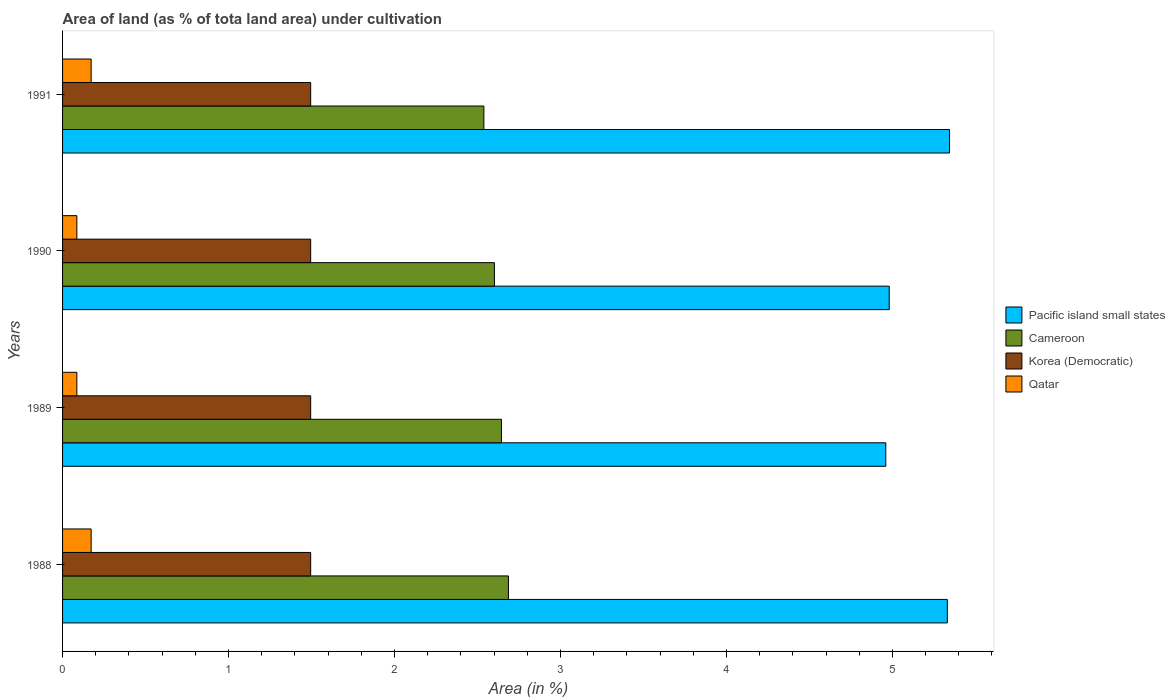How many different coloured bars are there?
Give a very brief answer. 4. Are the number of bars on each tick of the Y-axis equal?
Provide a succinct answer. Yes. How many bars are there on the 2nd tick from the bottom?
Your response must be concise. 4. What is the percentage of land under cultivation in Korea (Democratic) in 1991?
Offer a terse response. 1.49. Across all years, what is the maximum percentage of land under cultivation in Pacific island small states?
Your answer should be compact. 5.34. Across all years, what is the minimum percentage of land under cultivation in Cameroon?
Offer a very short reply. 2.54. In which year was the percentage of land under cultivation in Cameroon minimum?
Ensure brevity in your answer.  1991. What is the total percentage of land under cultivation in Pacific island small states in the graph?
Provide a short and direct response. 20.62. What is the difference between the percentage of land under cultivation in Korea (Democratic) in 1989 and that in 1991?
Offer a terse response. 0. What is the difference between the percentage of land under cultivation in Pacific island small states in 1988 and the percentage of land under cultivation in Cameroon in 1989?
Your answer should be very brief. 2.69. What is the average percentage of land under cultivation in Cameroon per year?
Your answer should be very brief. 2.62. In the year 1991, what is the difference between the percentage of land under cultivation in Korea (Democratic) and percentage of land under cultivation in Qatar?
Provide a succinct answer. 1.32. In how many years, is the percentage of land under cultivation in Qatar greater than 4.4 %?
Give a very brief answer. 0. What is the ratio of the percentage of land under cultivation in Cameroon in 1989 to that in 1991?
Your answer should be very brief. 1.04. Is the percentage of land under cultivation in Korea (Democratic) in 1988 less than that in 1989?
Keep it short and to the point. No. What is the difference between the highest and the second highest percentage of land under cultivation in Korea (Democratic)?
Your response must be concise. 0. What is the difference between the highest and the lowest percentage of land under cultivation in Pacific island small states?
Provide a short and direct response. 0.38. In how many years, is the percentage of land under cultivation in Pacific island small states greater than the average percentage of land under cultivation in Pacific island small states taken over all years?
Your answer should be very brief. 2. Is it the case that in every year, the sum of the percentage of land under cultivation in Pacific island small states and percentage of land under cultivation in Korea (Democratic) is greater than the sum of percentage of land under cultivation in Qatar and percentage of land under cultivation in Cameroon?
Provide a short and direct response. Yes. What does the 1st bar from the top in 1989 represents?
Your response must be concise. Qatar. What does the 1st bar from the bottom in 1990 represents?
Keep it short and to the point. Pacific island small states. Is it the case that in every year, the sum of the percentage of land under cultivation in Cameroon and percentage of land under cultivation in Qatar is greater than the percentage of land under cultivation in Korea (Democratic)?
Keep it short and to the point. Yes. How many bars are there?
Make the answer very short. 16. Are all the bars in the graph horizontal?
Offer a very short reply. Yes. Are the values on the major ticks of X-axis written in scientific E-notation?
Provide a succinct answer. No. Does the graph contain any zero values?
Offer a terse response. No. How are the legend labels stacked?
Keep it short and to the point. Vertical. What is the title of the graph?
Offer a terse response. Area of land (as % of tota land area) under cultivation. What is the label or title of the X-axis?
Keep it short and to the point. Area (in %). What is the Area (in %) of Pacific island small states in 1988?
Keep it short and to the point. 5.33. What is the Area (in %) of Cameroon in 1988?
Your answer should be compact. 2.69. What is the Area (in %) in Korea (Democratic) in 1988?
Offer a very short reply. 1.49. What is the Area (in %) in Qatar in 1988?
Offer a very short reply. 0.17. What is the Area (in %) in Pacific island small states in 1989?
Make the answer very short. 4.96. What is the Area (in %) of Cameroon in 1989?
Keep it short and to the point. 2.64. What is the Area (in %) of Korea (Democratic) in 1989?
Provide a succinct answer. 1.49. What is the Area (in %) of Qatar in 1989?
Provide a succinct answer. 0.09. What is the Area (in %) in Pacific island small states in 1990?
Provide a succinct answer. 4.98. What is the Area (in %) in Cameroon in 1990?
Your answer should be very brief. 2.6. What is the Area (in %) in Korea (Democratic) in 1990?
Your response must be concise. 1.49. What is the Area (in %) of Qatar in 1990?
Keep it short and to the point. 0.09. What is the Area (in %) in Pacific island small states in 1991?
Your response must be concise. 5.34. What is the Area (in %) of Cameroon in 1991?
Give a very brief answer. 2.54. What is the Area (in %) in Korea (Democratic) in 1991?
Give a very brief answer. 1.49. What is the Area (in %) of Qatar in 1991?
Your response must be concise. 0.17. Across all years, what is the maximum Area (in %) of Pacific island small states?
Your answer should be compact. 5.34. Across all years, what is the maximum Area (in %) in Cameroon?
Keep it short and to the point. 2.69. Across all years, what is the maximum Area (in %) of Korea (Democratic)?
Ensure brevity in your answer.  1.49. Across all years, what is the maximum Area (in %) of Qatar?
Your answer should be compact. 0.17. Across all years, what is the minimum Area (in %) in Pacific island small states?
Offer a very short reply. 4.96. Across all years, what is the minimum Area (in %) of Cameroon?
Make the answer very short. 2.54. Across all years, what is the minimum Area (in %) of Korea (Democratic)?
Provide a succinct answer. 1.49. Across all years, what is the minimum Area (in %) in Qatar?
Offer a terse response. 0.09. What is the total Area (in %) of Pacific island small states in the graph?
Offer a terse response. 20.62. What is the total Area (in %) in Cameroon in the graph?
Your answer should be compact. 10.47. What is the total Area (in %) in Korea (Democratic) in the graph?
Give a very brief answer. 5.98. What is the total Area (in %) in Qatar in the graph?
Your answer should be very brief. 0.52. What is the difference between the Area (in %) in Pacific island small states in 1988 and that in 1989?
Keep it short and to the point. 0.37. What is the difference between the Area (in %) in Cameroon in 1988 and that in 1989?
Ensure brevity in your answer.  0.04. What is the difference between the Area (in %) of Qatar in 1988 and that in 1989?
Provide a short and direct response. 0.09. What is the difference between the Area (in %) in Pacific island small states in 1988 and that in 1990?
Provide a succinct answer. 0.35. What is the difference between the Area (in %) of Cameroon in 1988 and that in 1990?
Provide a succinct answer. 0.08. What is the difference between the Area (in %) of Korea (Democratic) in 1988 and that in 1990?
Provide a succinct answer. 0. What is the difference between the Area (in %) of Qatar in 1988 and that in 1990?
Give a very brief answer. 0.09. What is the difference between the Area (in %) in Pacific island small states in 1988 and that in 1991?
Offer a terse response. -0.01. What is the difference between the Area (in %) of Cameroon in 1988 and that in 1991?
Provide a short and direct response. 0.15. What is the difference between the Area (in %) of Korea (Democratic) in 1988 and that in 1991?
Your answer should be very brief. 0. What is the difference between the Area (in %) of Qatar in 1988 and that in 1991?
Make the answer very short. 0. What is the difference between the Area (in %) of Pacific island small states in 1989 and that in 1990?
Provide a succinct answer. -0.02. What is the difference between the Area (in %) in Cameroon in 1989 and that in 1990?
Provide a succinct answer. 0.04. What is the difference between the Area (in %) in Pacific island small states in 1989 and that in 1991?
Keep it short and to the point. -0.38. What is the difference between the Area (in %) of Cameroon in 1989 and that in 1991?
Make the answer very short. 0.11. What is the difference between the Area (in %) in Qatar in 1989 and that in 1991?
Provide a succinct answer. -0.09. What is the difference between the Area (in %) in Pacific island small states in 1990 and that in 1991?
Your response must be concise. -0.36. What is the difference between the Area (in %) in Cameroon in 1990 and that in 1991?
Keep it short and to the point. 0.06. What is the difference between the Area (in %) in Korea (Democratic) in 1990 and that in 1991?
Keep it short and to the point. 0. What is the difference between the Area (in %) in Qatar in 1990 and that in 1991?
Ensure brevity in your answer.  -0.09. What is the difference between the Area (in %) of Pacific island small states in 1988 and the Area (in %) of Cameroon in 1989?
Your response must be concise. 2.69. What is the difference between the Area (in %) of Pacific island small states in 1988 and the Area (in %) of Korea (Democratic) in 1989?
Keep it short and to the point. 3.84. What is the difference between the Area (in %) of Pacific island small states in 1988 and the Area (in %) of Qatar in 1989?
Make the answer very short. 5.24. What is the difference between the Area (in %) in Cameroon in 1988 and the Area (in %) in Korea (Democratic) in 1989?
Ensure brevity in your answer.  1.19. What is the difference between the Area (in %) of Cameroon in 1988 and the Area (in %) of Qatar in 1989?
Provide a succinct answer. 2.6. What is the difference between the Area (in %) of Korea (Democratic) in 1988 and the Area (in %) of Qatar in 1989?
Give a very brief answer. 1.41. What is the difference between the Area (in %) in Pacific island small states in 1988 and the Area (in %) in Cameroon in 1990?
Ensure brevity in your answer.  2.73. What is the difference between the Area (in %) of Pacific island small states in 1988 and the Area (in %) of Korea (Democratic) in 1990?
Provide a short and direct response. 3.84. What is the difference between the Area (in %) of Pacific island small states in 1988 and the Area (in %) of Qatar in 1990?
Make the answer very short. 5.24. What is the difference between the Area (in %) in Cameroon in 1988 and the Area (in %) in Korea (Democratic) in 1990?
Offer a terse response. 1.19. What is the difference between the Area (in %) of Cameroon in 1988 and the Area (in %) of Qatar in 1990?
Give a very brief answer. 2.6. What is the difference between the Area (in %) of Korea (Democratic) in 1988 and the Area (in %) of Qatar in 1990?
Offer a terse response. 1.41. What is the difference between the Area (in %) in Pacific island small states in 1988 and the Area (in %) in Cameroon in 1991?
Provide a short and direct response. 2.79. What is the difference between the Area (in %) in Pacific island small states in 1988 and the Area (in %) in Korea (Democratic) in 1991?
Your response must be concise. 3.84. What is the difference between the Area (in %) of Pacific island small states in 1988 and the Area (in %) of Qatar in 1991?
Provide a short and direct response. 5.16. What is the difference between the Area (in %) in Cameroon in 1988 and the Area (in %) in Korea (Democratic) in 1991?
Your response must be concise. 1.19. What is the difference between the Area (in %) of Cameroon in 1988 and the Area (in %) of Qatar in 1991?
Provide a short and direct response. 2.51. What is the difference between the Area (in %) of Korea (Democratic) in 1988 and the Area (in %) of Qatar in 1991?
Your response must be concise. 1.32. What is the difference between the Area (in %) of Pacific island small states in 1989 and the Area (in %) of Cameroon in 1990?
Offer a terse response. 2.36. What is the difference between the Area (in %) of Pacific island small states in 1989 and the Area (in %) of Korea (Democratic) in 1990?
Your answer should be very brief. 3.47. What is the difference between the Area (in %) in Pacific island small states in 1989 and the Area (in %) in Qatar in 1990?
Your answer should be compact. 4.87. What is the difference between the Area (in %) of Cameroon in 1989 and the Area (in %) of Korea (Democratic) in 1990?
Provide a short and direct response. 1.15. What is the difference between the Area (in %) in Cameroon in 1989 and the Area (in %) in Qatar in 1990?
Your answer should be compact. 2.56. What is the difference between the Area (in %) in Korea (Democratic) in 1989 and the Area (in %) in Qatar in 1990?
Your response must be concise. 1.41. What is the difference between the Area (in %) of Pacific island small states in 1989 and the Area (in %) of Cameroon in 1991?
Offer a very short reply. 2.42. What is the difference between the Area (in %) of Pacific island small states in 1989 and the Area (in %) of Korea (Democratic) in 1991?
Your response must be concise. 3.47. What is the difference between the Area (in %) in Pacific island small states in 1989 and the Area (in %) in Qatar in 1991?
Provide a short and direct response. 4.79. What is the difference between the Area (in %) in Cameroon in 1989 and the Area (in %) in Korea (Democratic) in 1991?
Provide a short and direct response. 1.15. What is the difference between the Area (in %) in Cameroon in 1989 and the Area (in %) in Qatar in 1991?
Your response must be concise. 2.47. What is the difference between the Area (in %) of Korea (Democratic) in 1989 and the Area (in %) of Qatar in 1991?
Make the answer very short. 1.32. What is the difference between the Area (in %) in Pacific island small states in 1990 and the Area (in %) in Cameroon in 1991?
Offer a terse response. 2.44. What is the difference between the Area (in %) in Pacific island small states in 1990 and the Area (in %) in Korea (Democratic) in 1991?
Provide a succinct answer. 3.49. What is the difference between the Area (in %) in Pacific island small states in 1990 and the Area (in %) in Qatar in 1991?
Your answer should be very brief. 4.81. What is the difference between the Area (in %) of Cameroon in 1990 and the Area (in %) of Korea (Democratic) in 1991?
Provide a short and direct response. 1.11. What is the difference between the Area (in %) of Cameroon in 1990 and the Area (in %) of Qatar in 1991?
Make the answer very short. 2.43. What is the difference between the Area (in %) of Korea (Democratic) in 1990 and the Area (in %) of Qatar in 1991?
Offer a very short reply. 1.32. What is the average Area (in %) in Pacific island small states per year?
Your answer should be very brief. 5.15. What is the average Area (in %) of Cameroon per year?
Provide a short and direct response. 2.62. What is the average Area (in %) of Korea (Democratic) per year?
Keep it short and to the point. 1.49. What is the average Area (in %) of Qatar per year?
Keep it short and to the point. 0.13. In the year 1988, what is the difference between the Area (in %) in Pacific island small states and Area (in %) in Cameroon?
Keep it short and to the point. 2.64. In the year 1988, what is the difference between the Area (in %) in Pacific island small states and Area (in %) in Korea (Democratic)?
Keep it short and to the point. 3.84. In the year 1988, what is the difference between the Area (in %) in Pacific island small states and Area (in %) in Qatar?
Ensure brevity in your answer.  5.16. In the year 1988, what is the difference between the Area (in %) of Cameroon and Area (in %) of Korea (Democratic)?
Provide a succinct answer. 1.19. In the year 1988, what is the difference between the Area (in %) in Cameroon and Area (in %) in Qatar?
Offer a terse response. 2.51. In the year 1988, what is the difference between the Area (in %) in Korea (Democratic) and Area (in %) in Qatar?
Your answer should be compact. 1.32. In the year 1989, what is the difference between the Area (in %) of Pacific island small states and Area (in %) of Cameroon?
Your answer should be compact. 2.32. In the year 1989, what is the difference between the Area (in %) in Pacific island small states and Area (in %) in Korea (Democratic)?
Offer a terse response. 3.47. In the year 1989, what is the difference between the Area (in %) in Pacific island small states and Area (in %) in Qatar?
Offer a very short reply. 4.87. In the year 1989, what is the difference between the Area (in %) of Cameroon and Area (in %) of Korea (Democratic)?
Your answer should be compact. 1.15. In the year 1989, what is the difference between the Area (in %) of Cameroon and Area (in %) of Qatar?
Give a very brief answer. 2.56. In the year 1989, what is the difference between the Area (in %) of Korea (Democratic) and Area (in %) of Qatar?
Keep it short and to the point. 1.41. In the year 1990, what is the difference between the Area (in %) of Pacific island small states and Area (in %) of Cameroon?
Ensure brevity in your answer.  2.38. In the year 1990, what is the difference between the Area (in %) of Pacific island small states and Area (in %) of Korea (Democratic)?
Provide a short and direct response. 3.49. In the year 1990, what is the difference between the Area (in %) in Pacific island small states and Area (in %) in Qatar?
Offer a very short reply. 4.89. In the year 1990, what is the difference between the Area (in %) of Cameroon and Area (in %) of Korea (Democratic)?
Offer a terse response. 1.11. In the year 1990, what is the difference between the Area (in %) of Cameroon and Area (in %) of Qatar?
Offer a very short reply. 2.52. In the year 1990, what is the difference between the Area (in %) of Korea (Democratic) and Area (in %) of Qatar?
Provide a succinct answer. 1.41. In the year 1991, what is the difference between the Area (in %) in Pacific island small states and Area (in %) in Cameroon?
Your answer should be very brief. 2.81. In the year 1991, what is the difference between the Area (in %) in Pacific island small states and Area (in %) in Korea (Democratic)?
Keep it short and to the point. 3.85. In the year 1991, what is the difference between the Area (in %) in Pacific island small states and Area (in %) in Qatar?
Make the answer very short. 5.17. In the year 1991, what is the difference between the Area (in %) in Cameroon and Area (in %) in Korea (Democratic)?
Offer a terse response. 1.04. In the year 1991, what is the difference between the Area (in %) in Cameroon and Area (in %) in Qatar?
Keep it short and to the point. 2.37. In the year 1991, what is the difference between the Area (in %) in Korea (Democratic) and Area (in %) in Qatar?
Provide a succinct answer. 1.32. What is the ratio of the Area (in %) in Pacific island small states in 1988 to that in 1989?
Provide a succinct answer. 1.07. What is the ratio of the Area (in %) in Qatar in 1988 to that in 1989?
Provide a short and direct response. 2. What is the ratio of the Area (in %) of Pacific island small states in 1988 to that in 1990?
Your answer should be very brief. 1.07. What is the ratio of the Area (in %) of Cameroon in 1988 to that in 1990?
Keep it short and to the point. 1.03. What is the ratio of the Area (in %) of Korea (Democratic) in 1988 to that in 1990?
Give a very brief answer. 1. What is the ratio of the Area (in %) of Cameroon in 1988 to that in 1991?
Your answer should be very brief. 1.06. What is the ratio of the Area (in %) in Qatar in 1988 to that in 1991?
Ensure brevity in your answer.  1. What is the ratio of the Area (in %) of Pacific island small states in 1989 to that in 1990?
Keep it short and to the point. 1. What is the ratio of the Area (in %) of Cameroon in 1989 to that in 1990?
Give a very brief answer. 1.02. What is the ratio of the Area (in %) in Korea (Democratic) in 1989 to that in 1990?
Provide a succinct answer. 1. What is the ratio of the Area (in %) in Qatar in 1989 to that in 1990?
Your answer should be compact. 1. What is the ratio of the Area (in %) of Pacific island small states in 1989 to that in 1991?
Provide a short and direct response. 0.93. What is the ratio of the Area (in %) in Cameroon in 1989 to that in 1991?
Give a very brief answer. 1.04. What is the ratio of the Area (in %) in Pacific island small states in 1990 to that in 1991?
Keep it short and to the point. 0.93. What is the difference between the highest and the second highest Area (in %) of Pacific island small states?
Offer a very short reply. 0.01. What is the difference between the highest and the second highest Area (in %) in Cameroon?
Your answer should be very brief. 0.04. What is the difference between the highest and the second highest Area (in %) of Qatar?
Offer a very short reply. 0. What is the difference between the highest and the lowest Area (in %) of Pacific island small states?
Your answer should be compact. 0.38. What is the difference between the highest and the lowest Area (in %) in Cameroon?
Offer a terse response. 0.15. What is the difference between the highest and the lowest Area (in %) of Qatar?
Make the answer very short. 0.09. 